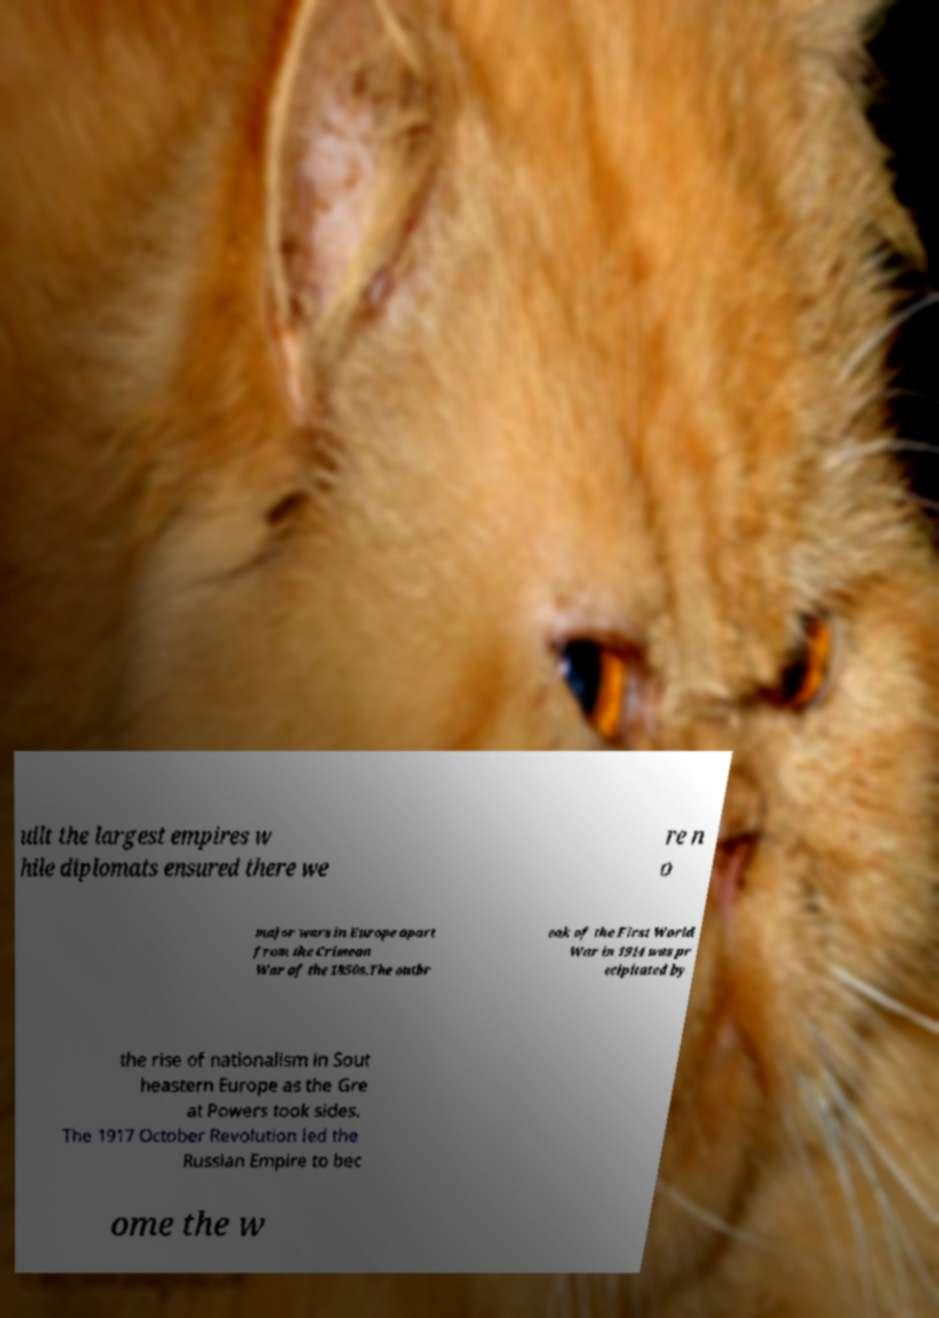Please read and relay the text visible in this image. What does it say? uilt the largest empires w hile diplomats ensured there we re n o major wars in Europe apart from the Crimean War of the 1850s.The outbr eak of the First World War in 1914 was pr ecipitated by the rise of nationalism in Sout heastern Europe as the Gre at Powers took sides. The 1917 October Revolution led the Russian Empire to bec ome the w 